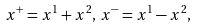<formula> <loc_0><loc_0><loc_500><loc_500>x ^ { + } = x ^ { 1 } + x ^ { 2 } , \, x ^ { - } = x ^ { 1 } - x ^ { 2 } ,</formula> 